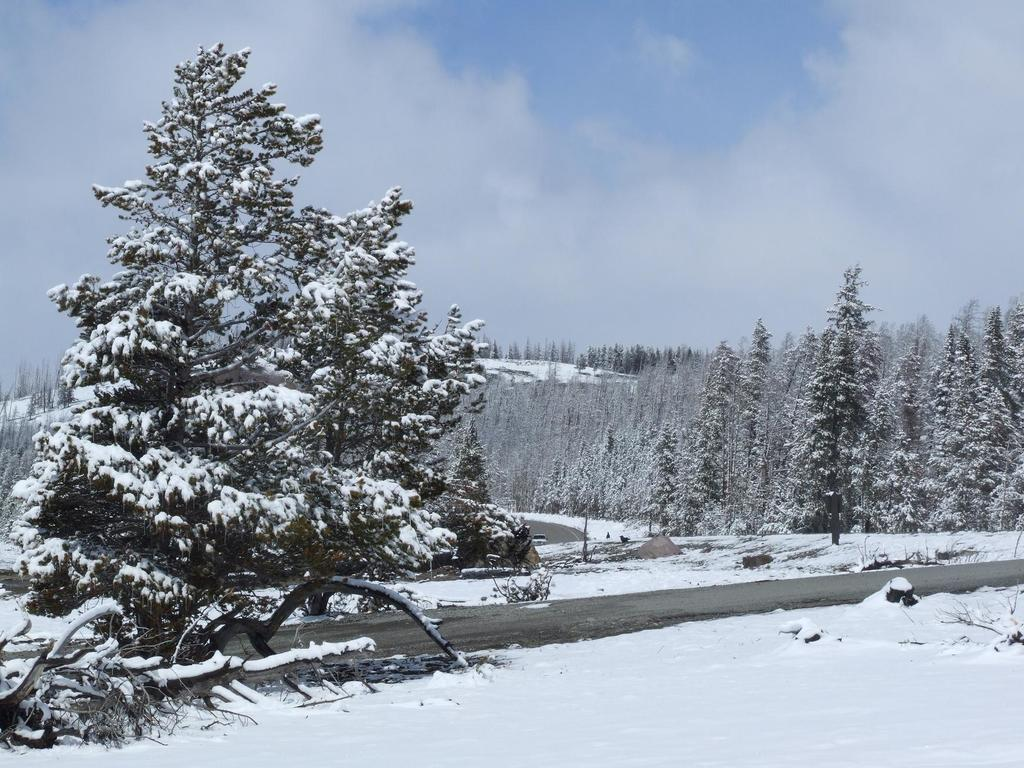What type of weather condition is depicted at the bottom of the image? There is snow at the bottom of the image, indicating a cold or wintry weather condition. What type of natural environment can be seen in the background of the image? There are trees in the background of the image, suggesting a forest or wooded area. What is visible at the top of the image? The sky is visible at the top of the image. What can be observed in the sky? Clouds are present in the sky. What is the value of the division between the trees and the snow in the image? There is no division between the trees and the snow in the image; they are both part of the same natural environment. 